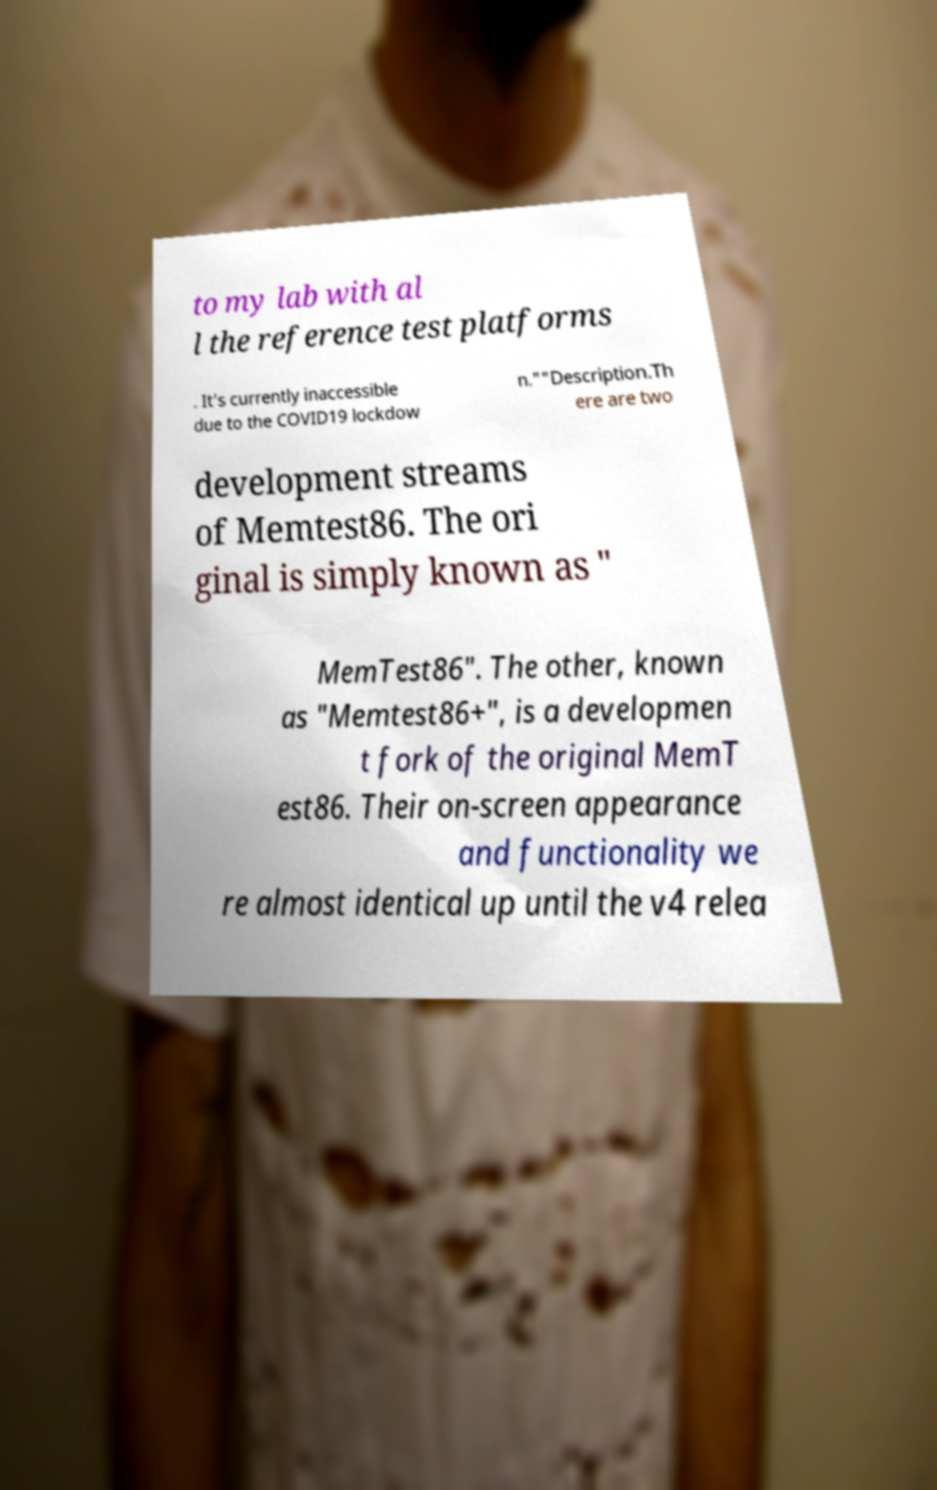There's text embedded in this image that I need extracted. Can you transcribe it verbatim? to my lab with al l the reference test platforms . It's currently inaccessible due to the COVID19 lockdow n.""Description.Th ere are two development streams of Memtest86. The ori ginal is simply known as " MemTest86". The other, known as "Memtest86+", is a developmen t fork of the original MemT est86. Their on-screen appearance and functionality we re almost identical up until the v4 relea 